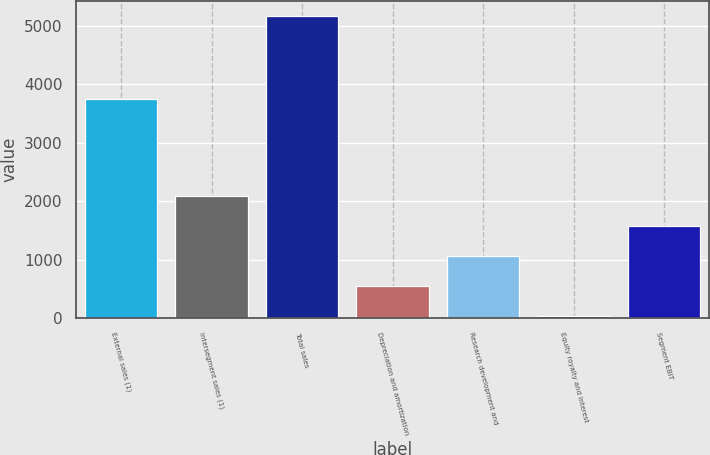<chart> <loc_0><loc_0><loc_500><loc_500><bar_chart><fcel>External sales (1)<fcel>Intersegment sales (1)<fcel>Total sales<fcel>Depreciation and amortization<fcel>Research development and<fcel>Equity royalty and interest<fcel>Segment EBIT<nl><fcel>3745<fcel>2089.8<fcel>5172<fcel>548.7<fcel>1062.4<fcel>35<fcel>1576.1<nl></chart> 